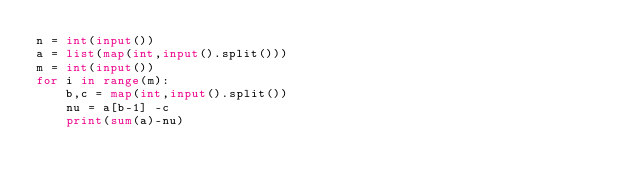Convert code to text. <code><loc_0><loc_0><loc_500><loc_500><_Python_>n = int(input())
a = list(map(int,input().split()))
m = int(input())
for i in range(m):
    b,c = map(int,input().split())
    nu = a[b-1] -c
    print(sum(a)-nu)</code> 